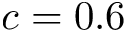<formula> <loc_0><loc_0><loc_500><loc_500>c = 0 . 6</formula> 